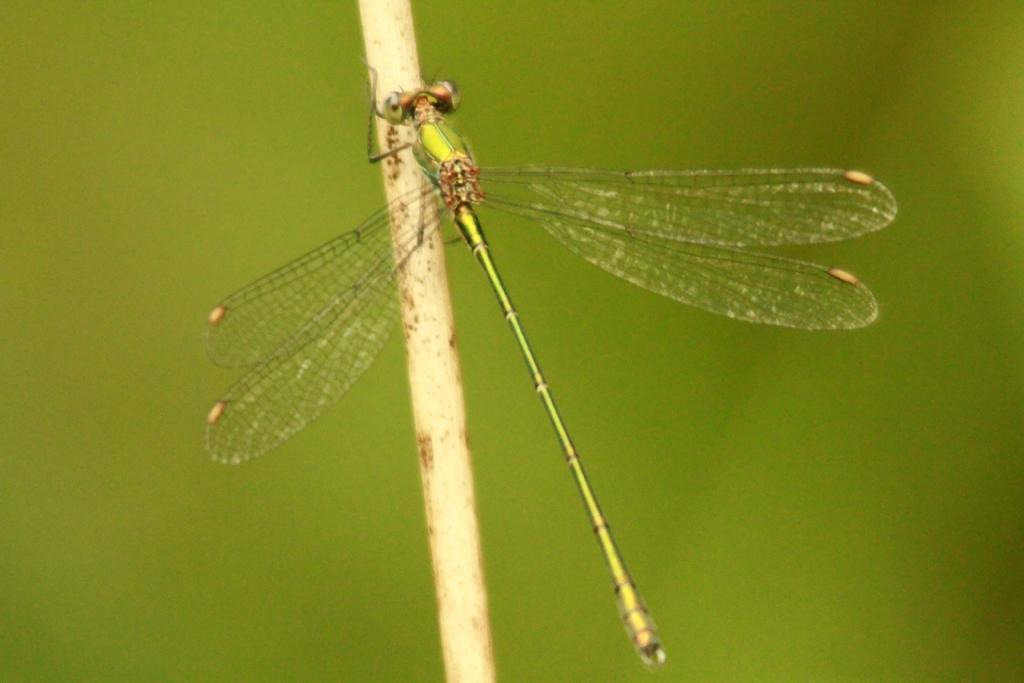Could you give a brief overview of what you see in this image? In this picture, we see a dragonfly. It is in green color. In the middle, we see a wooden stick. In the background, it is green in color. 